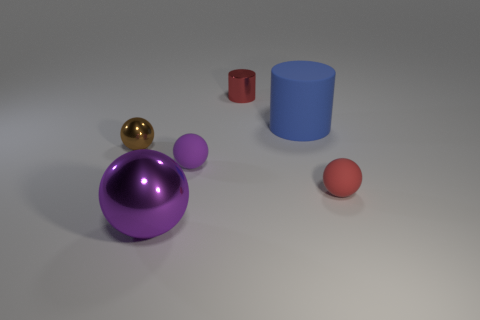How many purple spheres must be subtracted to get 1 purple spheres? 1 Subtract 1 cylinders. How many cylinders are left? 1 Add 1 tiny red matte balls. How many objects exist? 7 Subtract all tiny red matte spheres. How many spheres are left? 3 Subtract all red balls. How many balls are left? 3 Add 6 blue matte objects. How many blue matte objects exist? 7 Subtract 0 brown cylinders. How many objects are left? 6 Subtract all balls. How many objects are left? 2 Subtract all brown spheres. Subtract all cyan cylinders. How many spheres are left? 3 Subtract all cyan cylinders. How many gray spheres are left? 0 